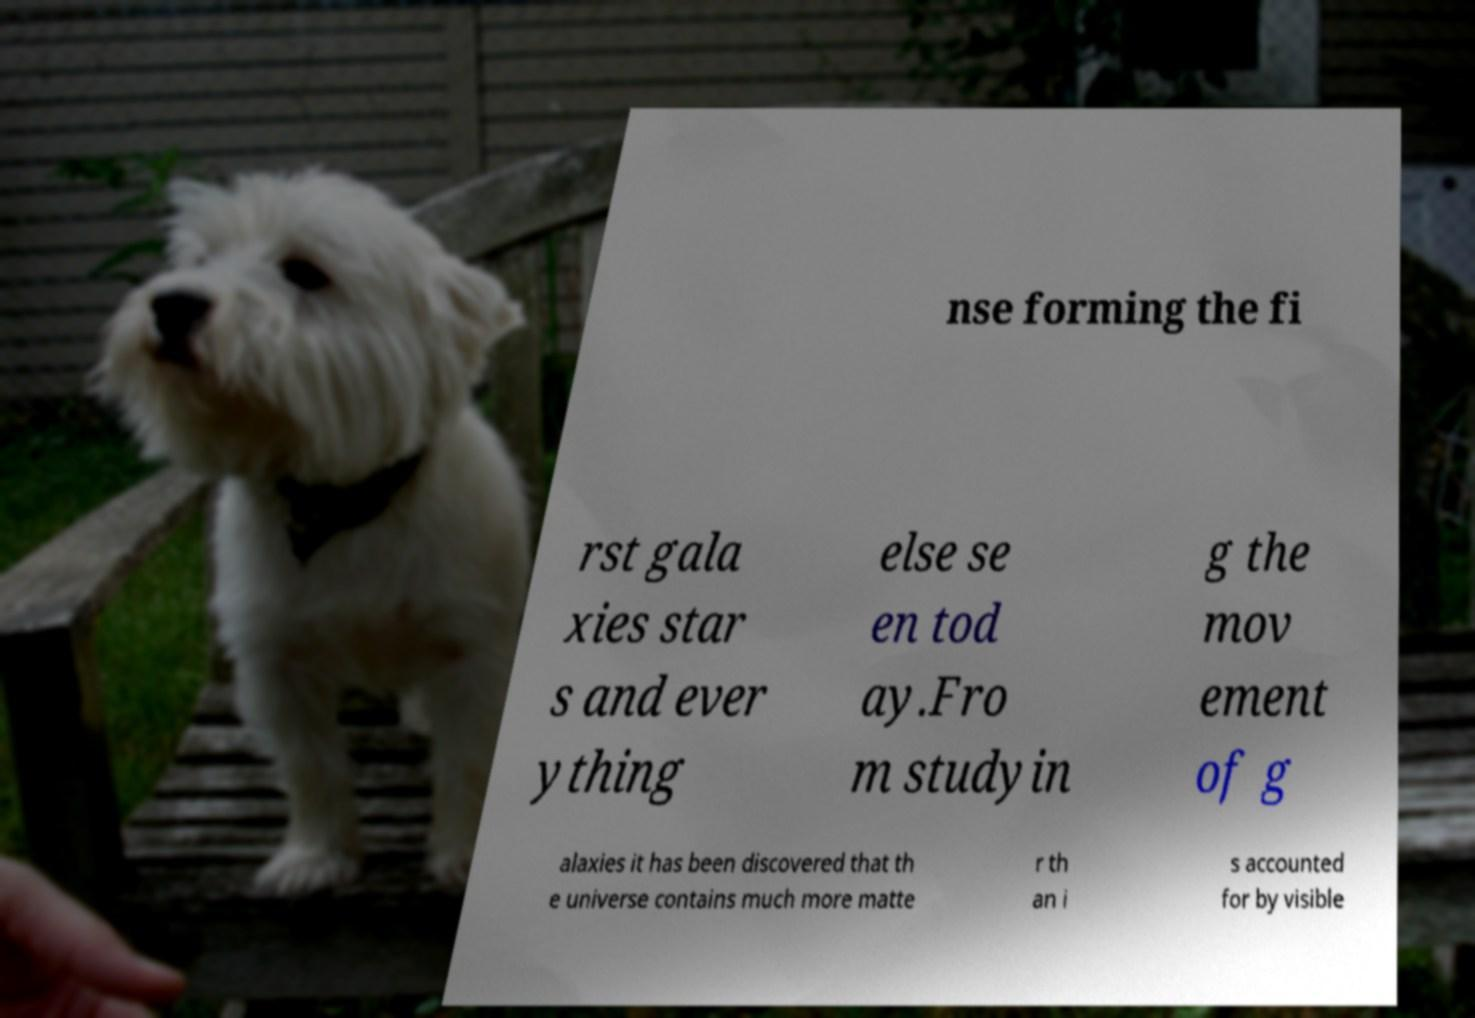For documentation purposes, I need the text within this image transcribed. Could you provide that? nse forming the fi rst gala xies star s and ever ything else se en tod ay.Fro m studyin g the mov ement of g alaxies it has been discovered that th e universe contains much more matte r th an i s accounted for by visible 